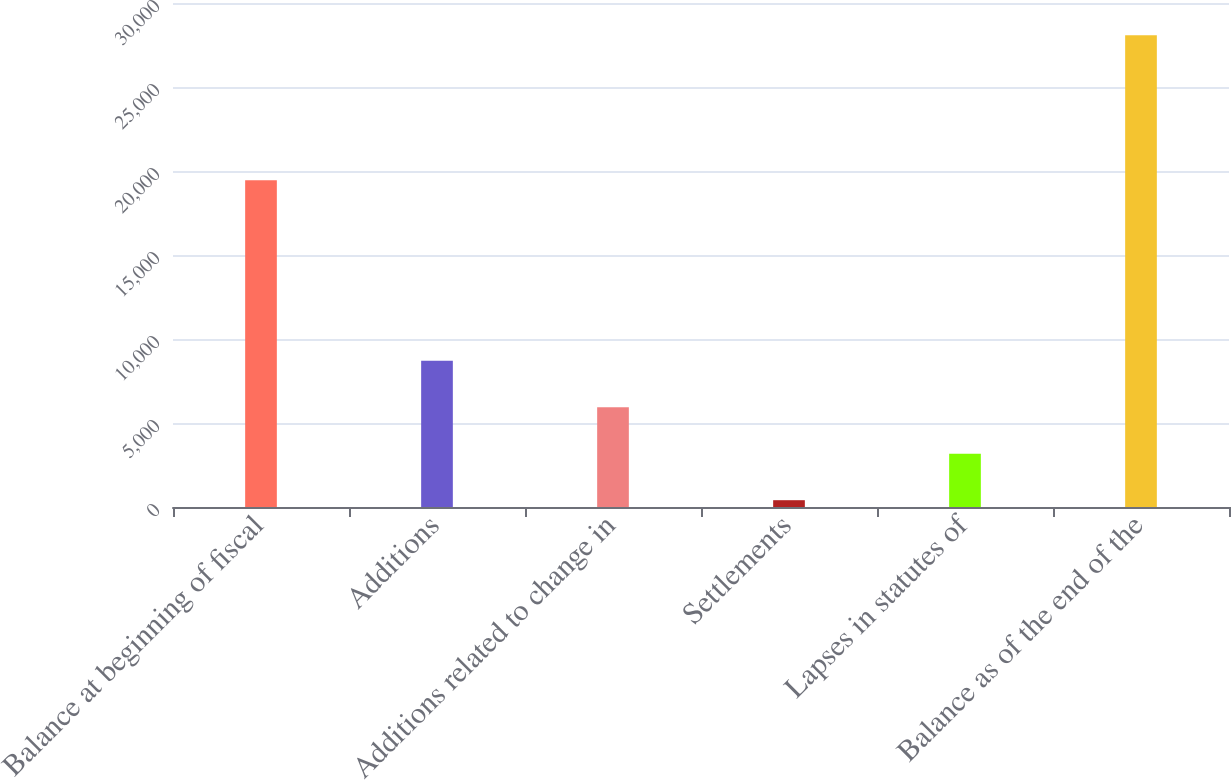<chart> <loc_0><loc_0><loc_500><loc_500><bar_chart><fcel>Balance at beginning of fiscal<fcel>Additions<fcel>Additions related to change in<fcel>Settlements<fcel>Lapses in statutes of<fcel>Balance as of the end of the<nl><fcel>19447<fcel>8705.4<fcel>5938.6<fcel>405<fcel>3171.8<fcel>28073<nl></chart> 